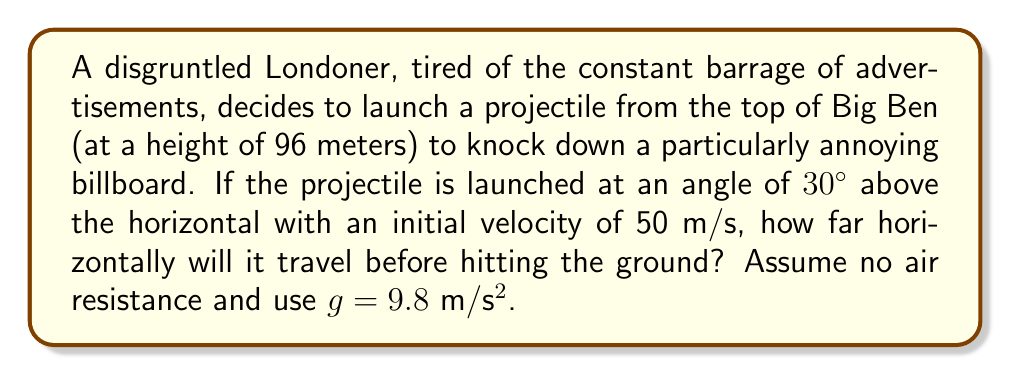Solve this math problem. To solve this problem, we'll use the equations of motion for projectile motion:

1) Horizontal motion: $x = v_0 \cos \theta \cdot t$
2) Vertical motion: $y = h_0 + v_0 \sin \theta \cdot t - \frac{1}{2}gt^2$

Where:
$x$ is the horizontal distance
$y$ is the vertical distance
$v_0$ is the initial velocity
$\theta$ is the launch angle
$t$ is the time
$h_0$ is the initial height
$g$ is the acceleration due to gravity

Step 1: Calculate the time of flight
At the point of impact, $y = 0$. We can use this to find the time:

$$0 = 96 + 50 \sin 30° \cdot t - \frac{1}{2}(9.8)t^2$$

Simplifying:
$$0 = 96 + 25t - 4.9t^2$$

This is a quadratic equation. Solving for t:

$$t = \frac{25 + \sqrt{25^2 + 4(4.9)(96)}}{2(4.9)} \approx 5.77 \text{ seconds}$$

Step 2: Calculate the horizontal distance
Now that we have the time, we can use the horizontal motion equation:

$$x = 50 \cos 30° \cdot 5.77$$

$$x = 50 \cdot \frac{\sqrt{3}}{2} \cdot 5.77 \approx 249.8 \text{ meters}$$

Therefore, the projectile will travel approximately 249.8 meters horizontally before hitting the ground.
Answer: 249.8 meters 